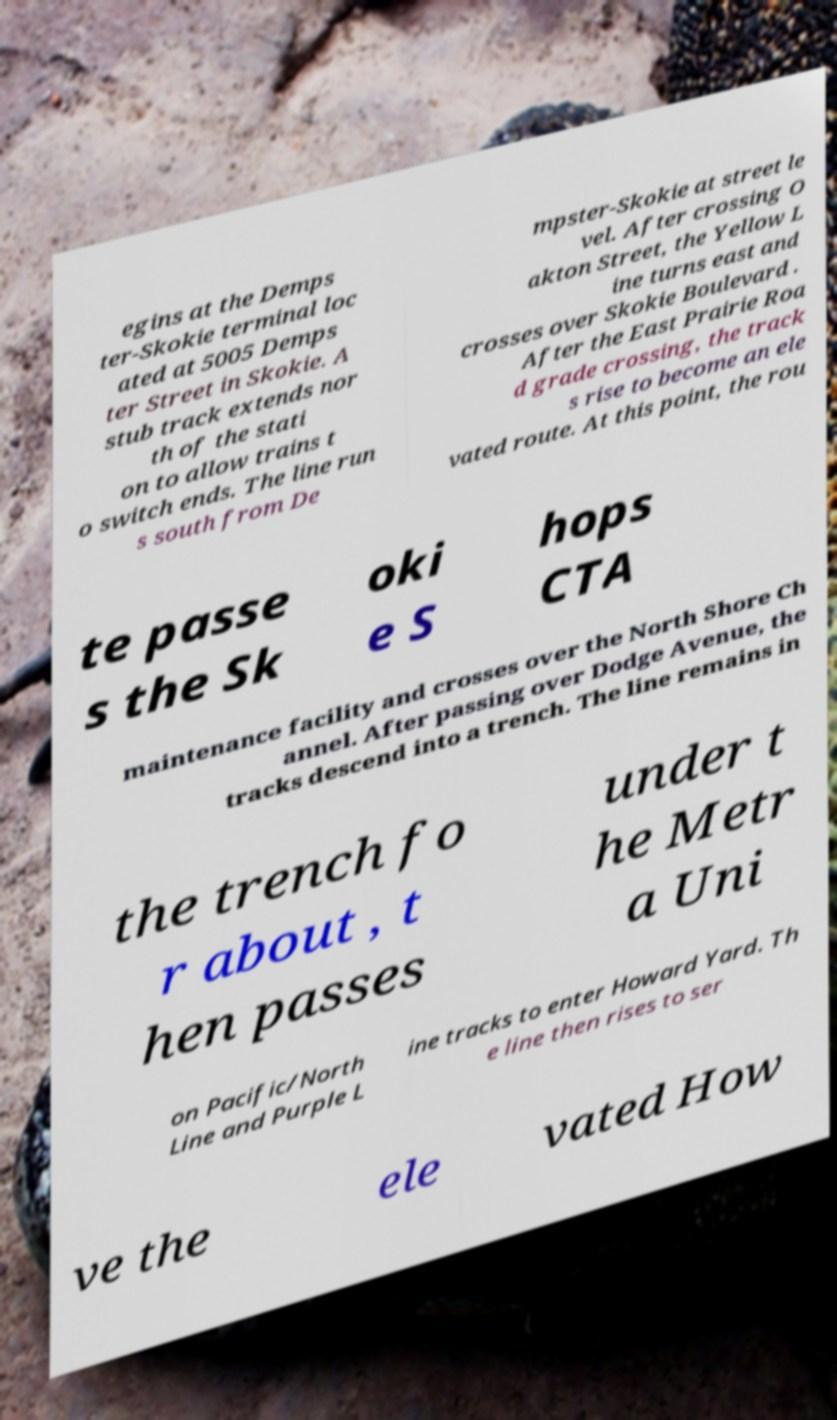There's text embedded in this image that I need extracted. Can you transcribe it verbatim? egins at the Demps ter-Skokie terminal loc ated at 5005 Demps ter Street in Skokie. A stub track extends nor th of the stati on to allow trains t o switch ends. The line run s south from De mpster-Skokie at street le vel. After crossing O akton Street, the Yellow L ine turns east and crosses over Skokie Boulevard . After the East Prairie Roa d grade crossing, the track s rise to become an ele vated route. At this point, the rou te passe s the Sk oki e S hops CTA maintenance facility and crosses over the North Shore Ch annel. After passing over Dodge Avenue, the tracks descend into a trench. The line remains in the trench fo r about , t hen passes under t he Metr a Uni on Pacific/North Line and Purple L ine tracks to enter Howard Yard. Th e line then rises to ser ve the ele vated How 